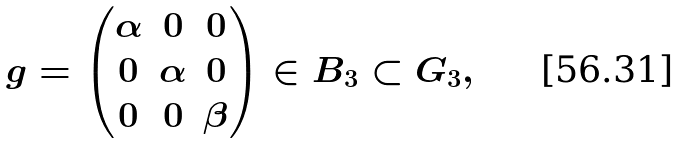Convert formula to latex. <formula><loc_0><loc_0><loc_500><loc_500>g = \begin{pmatrix} \alpha & 0 & 0 \\ 0 & \alpha & 0 \\ 0 & 0 & \beta \end{pmatrix} \in B _ { 3 } \subset G _ { 3 } ,</formula> 